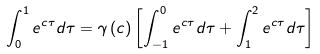<formula> <loc_0><loc_0><loc_500><loc_500>\int _ { 0 } ^ { 1 } e ^ { c \tau } d \tau = \gamma \left ( c \right ) \left [ \int _ { - 1 } ^ { 0 } e ^ { c \tau } d \tau + \int _ { 1 } ^ { 2 } e ^ { c \tau } d \tau \right ]</formula> 